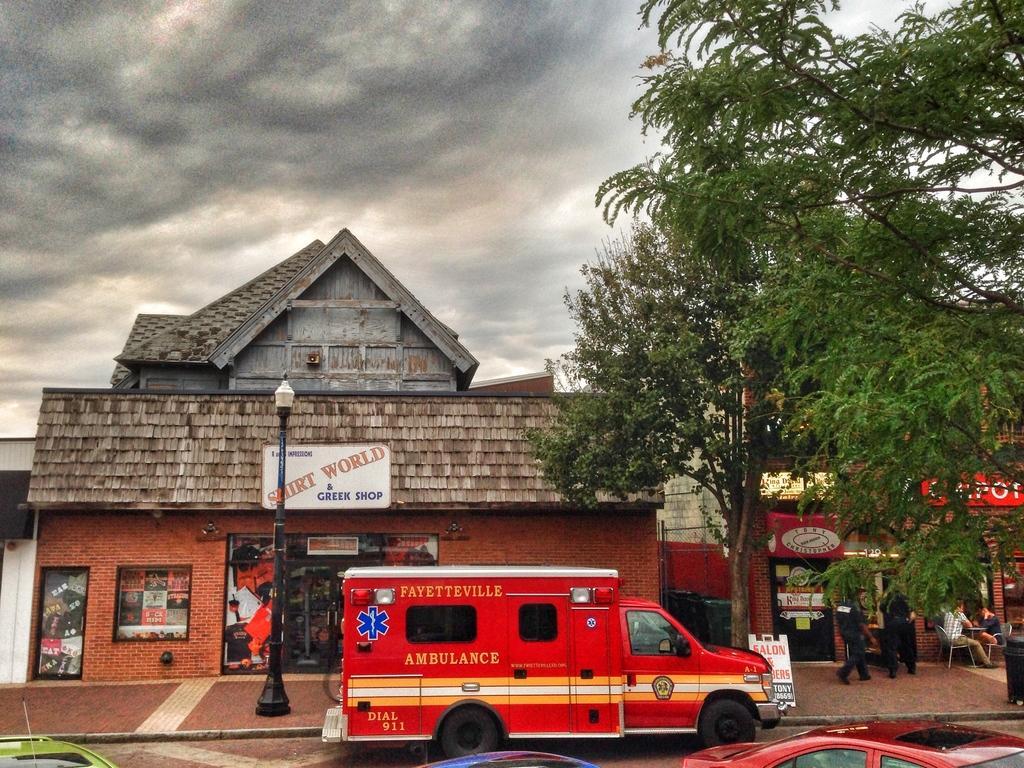How would you summarize this image in a sentence or two? In this image there are buildings, vehicles on the road, a street light, a tree and some clouds in the sky. 